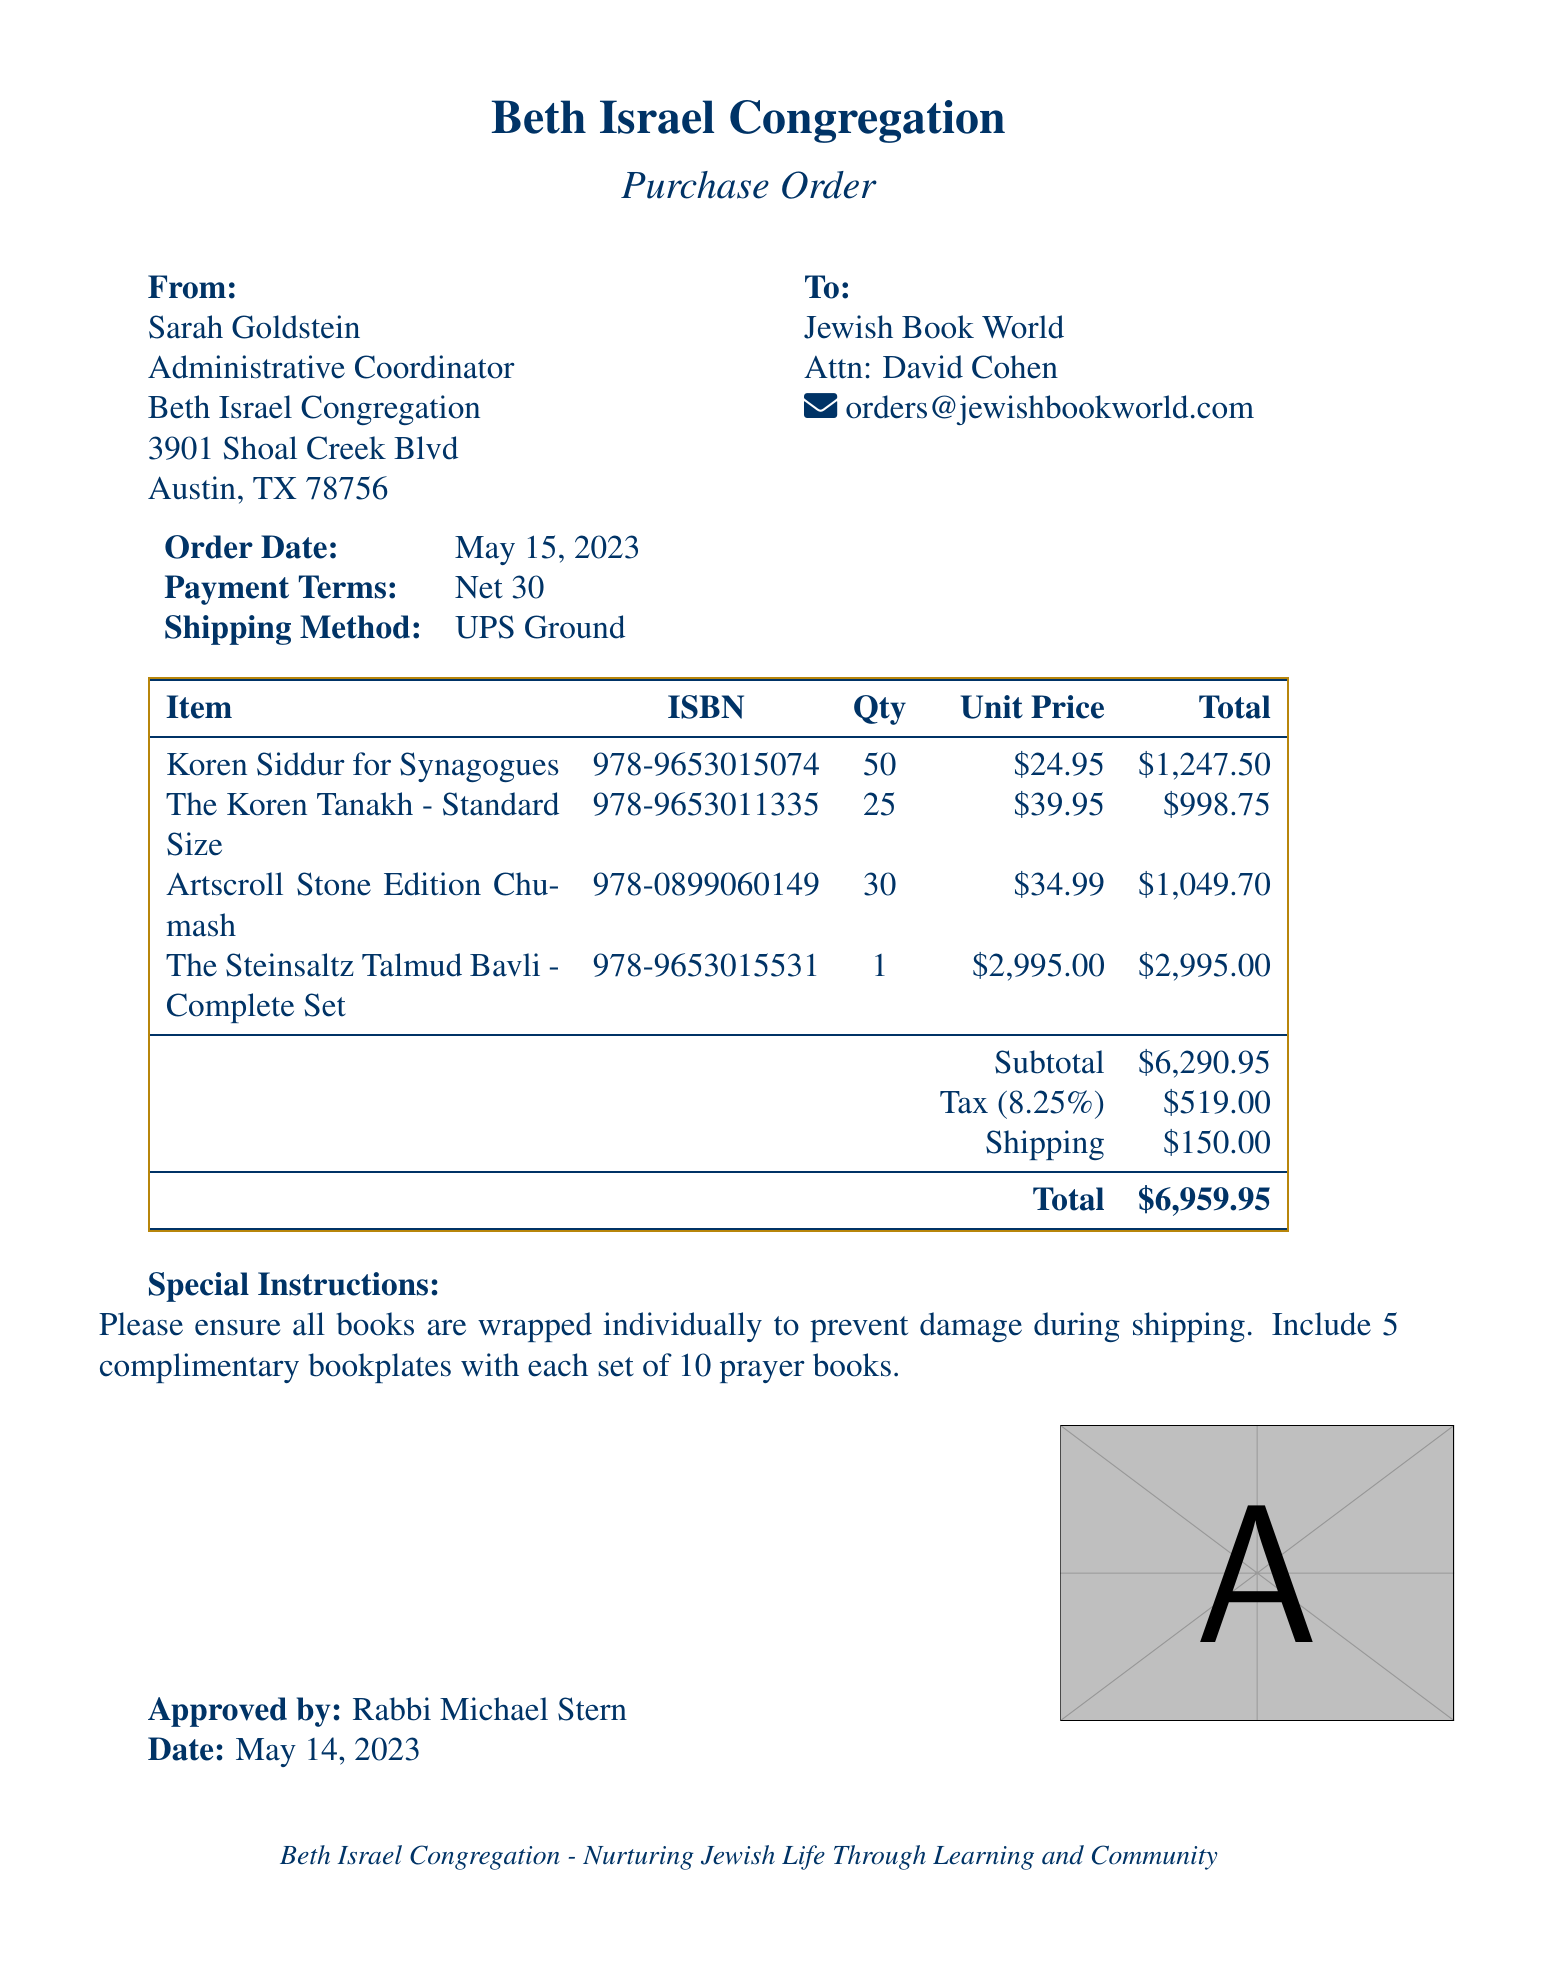What is the name of the synagogue? The name of the synagogue is listed at the top of the document.
Answer: Beth Israel Congregation Who is the Administrative Coordinator? The person coordinating the administrative tasks is mentioned as the sender of the purchase order.
Answer: Sarah Goldstein What is the total amount of the purchase order? The total amount is stated in the summary section of the document.
Answer: $6,959.95 How many Koren Siddur for Synagogues are ordered? The quantity of Koren Siddur is provided in the items list.
Answer: 50 What are the payment terms specified in the document? Payment terms can be found in the general information part of the document.
Answer: Net 30 What is the shipping cost for the order? The shipping cost is detailed in the summary section of the purchase order.
Answer: $150.00 Which supplier is providing the books? The supplier's name is mentioned in the order details.
Answer: Jewish Book World What is the ISBN of The Steinsaltz Talmud Bavli? The ISBN is listed next to the title in the items table.
Answer: 978-9653015531 What special instructions are included with the order? Special instructions are provided at the end of the order for handling the books.
Answer: Please ensure all books are wrapped individually to prevent damage during shipping. Include 5 complimentary bookplates with each set of 10 prayer books 